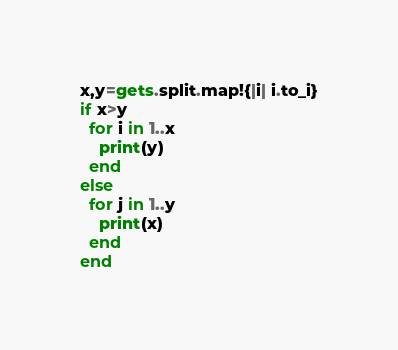Convert code to text. <code><loc_0><loc_0><loc_500><loc_500><_Ruby_>x,y=gets.split.map!{|i| i.to_i}
if x>y
  for i in 1..x
    print(y)
  end
else
  for j in 1..y
    print(x)
  end
end
</code> 